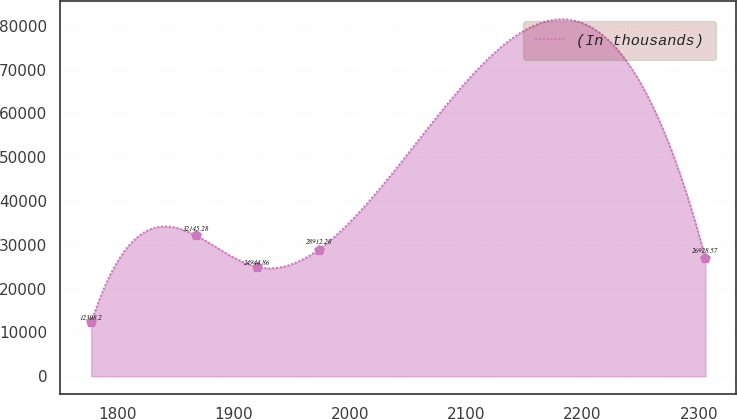<chart> <loc_0><loc_0><loc_500><loc_500><line_chart><ecel><fcel>(In thousands)<nl><fcel>1777.1<fcel>12308.2<nl><fcel>1867.06<fcel>32145.3<nl><fcel>1919.92<fcel>24944.9<nl><fcel>1972.78<fcel>28912.3<nl><fcel>2305.71<fcel>26928.6<nl></chart> 